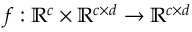<formula> <loc_0><loc_0><loc_500><loc_500>f \colon \mathbb { R } ^ { c } \times \mathbb { R } ^ { c \times d } \rightarrow \mathbb { R } ^ { c \times d }</formula> 